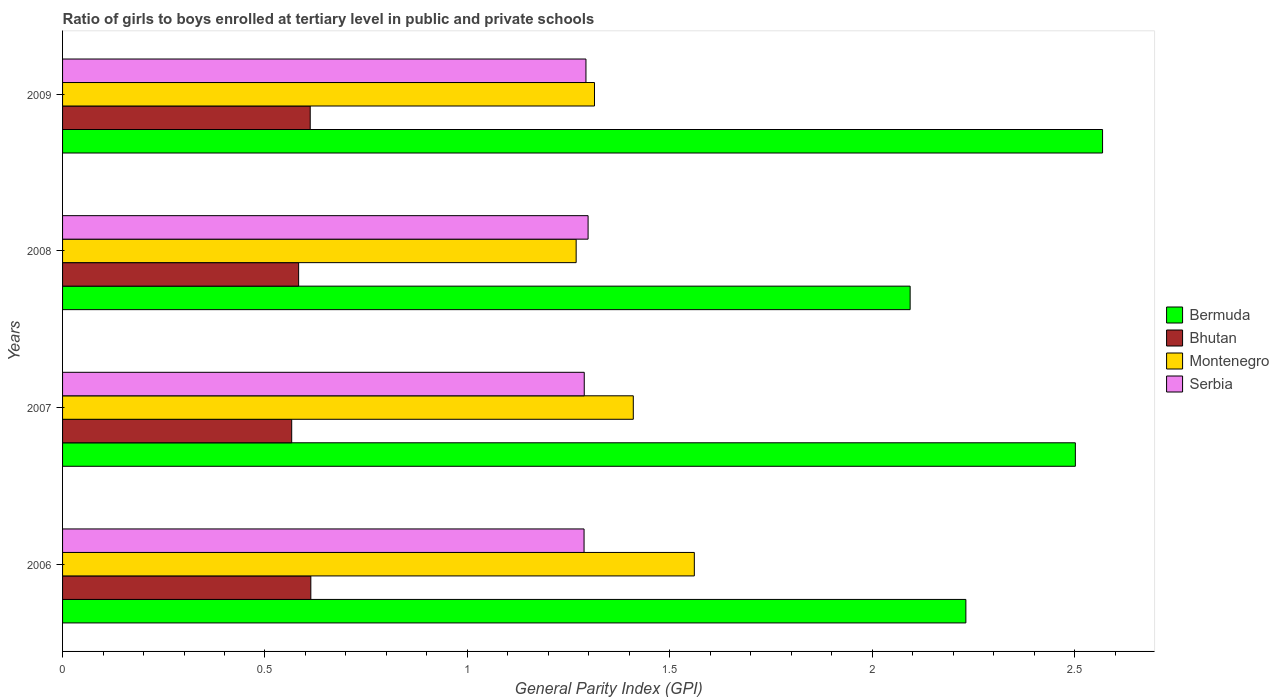How many different coloured bars are there?
Keep it short and to the point. 4. How many groups of bars are there?
Your answer should be compact. 4. Are the number of bars on each tick of the Y-axis equal?
Make the answer very short. Yes. How many bars are there on the 4th tick from the top?
Keep it short and to the point. 4. How many bars are there on the 4th tick from the bottom?
Make the answer very short. 4. What is the label of the 4th group of bars from the top?
Offer a terse response. 2006. In how many cases, is the number of bars for a given year not equal to the number of legend labels?
Provide a succinct answer. 0. What is the general parity index in Serbia in 2006?
Keep it short and to the point. 1.29. Across all years, what is the maximum general parity index in Bermuda?
Make the answer very short. 2.57. Across all years, what is the minimum general parity index in Serbia?
Your answer should be compact. 1.29. In which year was the general parity index in Bermuda maximum?
Offer a very short reply. 2009. What is the total general parity index in Bhutan in the graph?
Provide a succinct answer. 2.37. What is the difference between the general parity index in Bhutan in 2006 and that in 2008?
Provide a succinct answer. 0.03. What is the difference between the general parity index in Bhutan in 2006 and the general parity index in Bermuda in 2008?
Your answer should be compact. -1.48. What is the average general parity index in Bermuda per year?
Provide a short and direct response. 2.35. In the year 2006, what is the difference between the general parity index in Bermuda and general parity index in Montenegro?
Ensure brevity in your answer.  0.67. What is the ratio of the general parity index in Bhutan in 2007 to that in 2008?
Your answer should be compact. 0.97. What is the difference between the highest and the second highest general parity index in Montenegro?
Keep it short and to the point. 0.15. What is the difference between the highest and the lowest general parity index in Serbia?
Offer a terse response. 0.01. Is it the case that in every year, the sum of the general parity index in Bhutan and general parity index in Serbia is greater than the sum of general parity index in Bermuda and general parity index in Montenegro?
Provide a succinct answer. No. What does the 4th bar from the top in 2009 represents?
Make the answer very short. Bermuda. What does the 2nd bar from the bottom in 2009 represents?
Make the answer very short. Bhutan. Is it the case that in every year, the sum of the general parity index in Bhutan and general parity index in Bermuda is greater than the general parity index in Serbia?
Offer a terse response. Yes. Are all the bars in the graph horizontal?
Your answer should be compact. Yes. How many years are there in the graph?
Provide a succinct answer. 4. Are the values on the major ticks of X-axis written in scientific E-notation?
Keep it short and to the point. No. Does the graph contain grids?
Keep it short and to the point. No. How many legend labels are there?
Give a very brief answer. 4. What is the title of the graph?
Provide a succinct answer. Ratio of girls to boys enrolled at tertiary level in public and private schools. What is the label or title of the X-axis?
Your answer should be very brief. General Parity Index (GPI). What is the General Parity Index (GPI) in Bermuda in 2006?
Make the answer very short. 2.23. What is the General Parity Index (GPI) of Bhutan in 2006?
Give a very brief answer. 0.61. What is the General Parity Index (GPI) in Montenegro in 2006?
Keep it short and to the point. 1.56. What is the General Parity Index (GPI) of Serbia in 2006?
Ensure brevity in your answer.  1.29. What is the General Parity Index (GPI) in Bermuda in 2007?
Your answer should be very brief. 2.5. What is the General Parity Index (GPI) of Bhutan in 2007?
Keep it short and to the point. 0.57. What is the General Parity Index (GPI) in Montenegro in 2007?
Make the answer very short. 1.41. What is the General Parity Index (GPI) of Serbia in 2007?
Your answer should be compact. 1.29. What is the General Parity Index (GPI) of Bermuda in 2008?
Your answer should be compact. 2.09. What is the General Parity Index (GPI) of Bhutan in 2008?
Your answer should be very brief. 0.58. What is the General Parity Index (GPI) in Montenegro in 2008?
Provide a short and direct response. 1.27. What is the General Parity Index (GPI) in Serbia in 2008?
Offer a very short reply. 1.3. What is the General Parity Index (GPI) of Bermuda in 2009?
Provide a short and direct response. 2.57. What is the General Parity Index (GPI) in Bhutan in 2009?
Make the answer very short. 0.61. What is the General Parity Index (GPI) of Montenegro in 2009?
Provide a short and direct response. 1.31. What is the General Parity Index (GPI) of Serbia in 2009?
Keep it short and to the point. 1.29. Across all years, what is the maximum General Parity Index (GPI) in Bermuda?
Offer a terse response. 2.57. Across all years, what is the maximum General Parity Index (GPI) of Bhutan?
Offer a terse response. 0.61. Across all years, what is the maximum General Parity Index (GPI) in Montenegro?
Your answer should be very brief. 1.56. Across all years, what is the maximum General Parity Index (GPI) in Serbia?
Make the answer very short. 1.3. Across all years, what is the minimum General Parity Index (GPI) in Bermuda?
Provide a short and direct response. 2.09. Across all years, what is the minimum General Parity Index (GPI) in Bhutan?
Your answer should be compact. 0.57. Across all years, what is the minimum General Parity Index (GPI) in Montenegro?
Your response must be concise. 1.27. Across all years, what is the minimum General Parity Index (GPI) of Serbia?
Offer a very short reply. 1.29. What is the total General Parity Index (GPI) in Bermuda in the graph?
Provide a succinct answer. 9.4. What is the total General Parity Index (GPI) in Bhutan in the graph?
Give a very brief answer. 2.37. What is the total General Parity Index (GPI) of Montenegro in the graph?
Provide a succinct answer. 5.55. What is the total General Parity Index (GPI) of Serbia in the graph?
Your answer should be very brief. 5.17. What is the difference between the General Parity Index (GPI) of Bermuda in 2006 and that in 2007?
Your answer should be very brief. -0.27. What is the difference between the General Parity Index (GPI) in Bhutan in 2006 and that in 2007?
Make the answer very short. 0.05. What is the difference between the General Parity Index (GPI) of Montenegro in 2006 and that in 2007?
Your answer should be compact. 0.15. What is the difference between the General Parity Index (GPI) of Serbia in 2006 and that in 2007?
Provide a succinct answer. -0. What is the difference between the General Parity Index (GPI) of Bermuda in 2006 and that in 2008?
Your answer should be compact. 0.14. What is the difference between the General Parity Index (GPI) of Bhutan in 2006 and that in 2008?
Your response must be concise. 0.03. What is the difference between the General Parity Index (GPI) of Montenegro in 2006 and that in 2008?
Your answer should be very brief. 0.29. What is the difference between the General Parity Index (GPI) of Serbia in 2006 and that in 2008?
Make the answer very short. -0.01. What is the difference between the General Parity Index (GPI) in Bermuda in 2006 and that in 2009?
Give a very brief answer. -0.34. What is the difference between the General Parity Index (GPI) in Bhutan in 2006 and that in 2009?
Your answer should be compact. 0. What is the difference between the General Parity Index (GPI) in Montenegro in 2006 and that in 2009?
Provide a succinct answer. 0.25. What is the difference between the General Parity Index (GPI) in Serbia in 2006 and that in 2009?
Provide a succinct answer. -0. What is the difference between the General Parity Index (GPI) of Bermuda in 2007 and that in 2008?
Ensure brevity in your answer.  0.41. What is the difference between the General Parity Index (GPI) in Bhutan in 2007 and that in 2008?
Provide a short and direct response. -0.02. What is the difference between the General Parity Index (GPI) of Montenegro in 2007 and that in 2008?
Your answer should be compact. 0.14. What is the difference between the General Parity Index (GPI) of Serbia in 2007 and that in 2008?
Your answer should be compact. -0.01. What is the difference between the General Parity Index (GPI) in Bermuda in 2007 and that in 2009?
Offer a very short reply. -0.07. What is the difference between the General Parity Index (GPI) in Bhutan in 2007 and that in 2009?
Make the answer very short. -0.05. What is the difference between the General Parity Index (GPI) of Montenegro in 2007 and that in 2009?
Ensure brevity in your answer.  0.1. What is the difference between the General Parity Index (GPI) of Serbia in 2007 and that in 2009?
Your answer should be very brief. -0. What is the difference between the General Parity Index (GPI) of Bermuda in 2008 and that in 2009?
Your response must be concise. -0.48. What is the difference between the General Parity Index (GPI) in Bhutan in 2008 and that in 2009?
Give a very brief answer. -0.03. What is the difference between the General Parity Index (GPI) in Montenegro in 2008 and that in 2009?
Provide a short and direct response. -0.05. What is the difference between the General Parity Index (GPI) of Serbia in 2008 and that in 2009?
Make the answer very short. 0.01. What is the difference between the General Parity Index (GPI) of Bermuda in 2006 and the General Parity Index (GPI) of Bhutan in 2007?
Offer a terse response. 1.67. What is the difference between the General Parity Index (GPI) in Bermuda in 2006 and the General Parity Index (GPI) in Montenegro in 2007?
Give a very brief answer. 0.82. What is the difference between the General Parity Index (GPI) in Bermuda in 2006 and the General Parity Index (GPI) in Serbia in 2007?
Ensure brevity in your answer.  0.94. What is the difference between the General Parity Index (GPI) in Bhutan in 2006 and the General Parity Index (GPI) in Montenegro in 2007?
Provide a succinct answer. -0.8. What is the difference between the General Parity Index (GPI) of Bhutan in 2006 and the General Parity Index (GPI) of Serbia in 2007?
Make the answer very short. -0.68. What is the difference between the General Parity Index (GPI) in Montenegro in 2006 and the General Parity Index (GPI) in Serbia in 2007?
Keep it short and to the point. 0.27. What is the difference between the General Parity Index (GPI) in Bermuda in 2006 and the General Parity Index (GPI) in Bhutan in 2008?
Your response must be concise. 1.65. What is the difference between the General Parity Index (GPI) of Bermuda in 2006 and the General Parity Index (GPI) of Montenegro in 2008?
Provide a succinct answer. 0.96. What is the difference between the General Parity Index (GPI) in Bermuda in 2006 and the General Parity Index (GPI) in Serbia in 2008?
Ensure brevity in your answer.  0.93. What is the difference between the General Parity Index (GPI) in Bhutan in 2006 and the General Parity Index (GPI) in Montenegro in 2008?
Your response must be concise. -0.66. What is the difference between the General Parity Index (GPI) of Bhutan in 2006 and the General Parity Index (GPI) of Serbia in 2008?
Your answer should be compact. -0.68. What is the difference between the General Parity Index (GPI) in Montenegro in 2006 and the General Parity Index (GPI) in Serbia in 2008?
Make the answer very short. 0.26. What is the difference between the General Parity Index (GPI) of Bermuda in 2006 and the General Parity Index (GPI) of Bhutan in 2009?
Keep it short and to the point. 1.62. What is the difference between the General Parity Index (GPI) of Bermuda in 2006 and the General Parity Index (GPI) of Montenegro in 2009?
Provide a short and direct response. 0.92. What is the difference between the General Parity Index (GPI) of Bermuda in 2006 and the General Parity Index (GPI) of Serbia in 2009?
Provide a short and direct response. 0.94. What is the difference between the General Parity Index (GPI) of Bhutan in 2006 and the General Parity Index (GPI) of Montenegro in 2009?
Your response must be concise. -0.7. What is the difference between the General Parity Index (GPI) of Bhutan in 2006 and the General Parity Index (GPI) of Serbia in 2009?
Provide a short and direct response. -0.68. What is the difference between the General Parity Index (GPI) of Montenegro in 2006 and the General Parity Index (GPI) of Serbia in 2009?
Your answer should be compact. 0.27. What is the difference between the General Parity Index (GPI) of Bermuda in 2007 and the General Parity Index (GPI) of Bhutan in 2008?
Offer a very short reply. 1.92. What is the difference between the General Parity Index (GPI) in Bermuda in 2007 and the General Parity Index (GPI) in Montenegro in 2008?
Keep it short and to the point. 1.23. What is the difference between the General Parity Index (GPI) in Bermuda in 2007 and the General Parity Index (GPI) in Serbia in 2008?
Your answer should be compact. 1.2. What is the difference between the General Parity Index (GPI) of Bhutan in 2007 and the General Parity Index (GPI) of Montenegro in 2008?
Make the answer very short. -0.7. What is the difference between the General Parity Index (GPI) of Bhutan in 2007 and the General Parity Index (GPI) of Serbia in 2008?
Make the answer very short. -0.73. What is the difference between the General Parity Index (GPI) in Montenegro in 2007 and the General Parity Index (GPI) in Serbia in 2008?
Keep it short and to the point. 0.11. What is the difference between the General Parity Index (GPI) of Bermuda in 2007 and the General Parity Index (GPI) of Bhutan in 2009?
Keep it short and to the point. 1.89. What is the difference between the General Parity Index (GPI) of Bermuda in 2007 and the General Parity Index (GPI) of Montenegro in 2009?
Offer a very short reply. 1.19. What is the difference between the General Parity Index (GPI) in Bermuda in 2007 and the General Parity Index (GPI) in Serbia in 2009?
Keep it short and to the point. 1.21. What is the difference between the General Parity Index (GPI) of Bhutan in 2007 and the General Parity Index (GPI) of Montenegro in 2009?
Offer a terse response. -0.75. What is the difference between the General Parity Index (GPI) of Bhutan in 2007 and the General Parity Index (GPI) of Serbia in 2009?
Give a very brief answer. -0.73. What is the difference between the General Parity Index (GPI) of Montenegro in 2007 and the General Parity Index (GPI) of Serbia in 2009?
Offer a terse response. 0.12. What is the difference between the General Parity Index (GPI) in Bermuda in 2008 and the General Parity Index (GPI) in Bhutan in 2009?
Ensure brevity in your answer.  1.48. What is the difference between the General Parity Index (GPI) in Bermuda in 2008 and the General Parity Index (GPI) in Montenegro in 2009?
Offer a terse response. 0.78. What is the difference between the General Parity Index (GPI) of Bermuda in 2008 and the General Parity Index (GPI) of Serbia in 2009?
Your answer should be very brief. 0.8. What is the difference between the General Parity Index (GPI) of Bhutan in 2008 and the General Parity Index (GPI) of Montenegro in 2009?
Your response must be concise. -0.73. What is the difference between the General Parity Index (GPI) in Bhutan in 2008 and the General Parity Index (GPI) in Serbia in 2009?
Offer a very short reply. -0.71. What is the difference between the General Parity Index (GPI) in Montenegro in 2008 and the General Parity Index (GPI) in Serbia in 2009?
Your response must be concise. -0.02. What is the average General Parity Index (GPI) in Bermuda per year?
Ensure brevity in your answer.  2.35. What is the average General Parity Index (GPI) in Bhutan per year?
Offer a very short reply. 0.59. What is the average General Parity Index (GPI) in Montenegro per year?
Your answer should be very brief. 1.39. What is the average General Parity Index (GPI) in Serbia per year?
Make the answer very short. 1.29. In the year 2006, what is the difference between the General Parity Index (GPI) in Bermuda and General Parity Index (GPI) in Bhutan?
Provide a succinct answer. 1.62. In the year 2006, what is the difference between the General Parity Index (GPI) of Bermuda and General Parity Index (GPI) of Montenegro?
Provide a short and direct response. 0.67. In the year 2006, what is the difference between the General Parity Index (GPI) in Bermuda and General Parity Index (GPI) in Serbia?
Give a very brief answer. 0.94. In the year 2006, what is the difference between the General Parity Index (GPI) of Bhutan and General Parity Index (GPI) of Montenegro?
Your answer should be very brief. -0.95. In the year 2006, what is the difference between the General Parity Index (GPI) in Bhutan and General Parity Index (GPI) in Serbia?
Ensure brevity in your answer.  -0.67. In the year 2006, what is the difference between the General Parity Index (GPI) in Montenegro and General Parity Index (GPI) in Serbia?
Ensure brevity in your answer.  0.27. In the year 2007, what is the difference between the General Parity Index (GPI) in Bermuda and General Parity Index (GPI) in Bhutan?
Offer a terse response. 1.94. In the year 2007, what is the difference between the General Parity Index (GPI) of Bermuda and General Parity Index (GPI) of Montenegro?
Provide a succinct answer. 1.09. In the year 2007, what is the difference between the General Parity Index (GPI) of Bermuda and General Parity Index (GPI) of Serbia?
Ensure brevity in your answer.  1.21. In the year 2007, what is the difference between the General Parity Index (GPI) in Bhutan and General Parity Index (GPI) in Montenegro?
Offer a very short reply. -0.84. In the year 2007, what is the difference between the General Parity Index (GPI) in Bhutan and General Parity Index (GPI) in Serbia?
Give a very brief answer. -0.72. In the year 2007, what is the difference between the General Parity Index (GPI) of Montenegro and General Parity Index (GPI) of Serbia?
Your answer should be compact. 0.12. In the year 2008, what is the difference between the General Parity Index (GPI) of Bermuda and General Parity Index (GPI) of Bhutan?
Offer a very short reply. 1.51. In the year 2008, what is the difference between the General Parity Index (GPI) in Bermuda and General Parity Index (GPI) in Montenegro?
Your answer should be very brief. 0.82. In the year 2008, what is the difference between the General Parity Index (GPI) in Bermuda and General Parity Index (GPI) in Serbia?
Your response must be concise. 0.8. In the year 2008, what is the difference between the General Parity Index (GPI) of Bhutan and General Parity Index (GPI) of Montenegro?
Offer a terse response. -0.69. In the year 2008, what is the difference between the General Parity Index (GPI) of Bhutan and General Parity Index (GPI) of Serbia?
Keep it short and to the point. -0.71. In the year 2008, what is the difference between the General Parity Index (GPI) of Montenegro and General Parity Index (GPI) of Serbia?
Ensure brevity in your answer.  -0.03. In the year 2009, what is the difference between the General Parity Index (GPI) in Bermuda and General Parity Index (GPI) in Bhutan?
Your answer should be very brief. 1.96. In the year 2009, what is the difference between the General Parity Index (GPI) of Bermuda and General Parity Index (GPI) of Montenegro?
Your answer should be compact. 1.25. In the year 2009, what is the difference between the General Parity Index (GPI) in Bermuda and General Parity Index (GPI) in Serbia?
Make the answer very short. 1.28. In the year 2009, what is the difference between the General Parity Index (GPI) in Bhutan and General Parity Index (GPI) in Montenegro?
Your answer should be compact. -0.7. In the year 2009, what is the difference between the General Parity Index (GPI) of Bhutan and General Parity Index (GPI) of Serbia?
Make the answer very short. -0.68. In the year 2009, what is the difference between the General Parity Index (GPI) of Montenegro and General Parity Index (GPI) of Serbia?
Offer a terse response. 0.02. What is the ratio of the General Parity Index (GPI) of Bermuda in 2006 to that in 2007?
Provide a succinct answer. 0.89. What is the ratio of the General Parity Index (GPI) in Bhutan in 2006 to that in 2007?
Ensure brevity in your answer.  1.08. What is the ratio of the General Parity Index (GPI) in Montenegro in 2006 to that in 2007?
Make the answer very short. 1.11. What is the ratio of the General Parity Index (GPI) of Bermuda in 2006 to that in 2008?
Your answer should be very brief. 1.07. What is the ratio of the General Parity Index (GPI) in Bhutan in 2006 to that in 2008?
Provide a succinct answer. 1.05. What is the ratio of the General Parity Index (GPI) of Montenegro in 2006 to that in 2008?
Give a very brief answer. 1.23. What is the ratio of the General Parity Index (GPI) in Bermuda in 2006 to that in 2009?
Offer a very short reply. 0.87. What is the ratio of the General Parity Index (GPI) in Montenegro in 2006 to that in 2009?
Your response must be concise. 1.19. What is the ratio of the General Parity Index (GPI) of Bermuda in 2007 to that in 2008?
Your response must be concise. 1.19. What is the ratio of the General Parity Index (GPI) in Bhutan in 2007 to that in 2008?
Make the answer very short. 0.97. What is the ratio of the General Parity Index (GPI) of Montenegro in 2007 to that in 2008?
Offer a very short reply. 1.11. What is the ratio of the General Parity Index (GPI) in Bermuda in 2007 to that in 2009?
Your answer should be compact. 0.97. What is the ratio of the General Parity Index (GPI) in Bhutan in 2007 to that in 2009?
Offer a very short reply. 0.93. What is the ratio of the General Parity Index (GPI) of Montenegro in 2007 to that in 2009?
Your answer should be very brief. 1.07. What is the ratio of the General Parity Index (GPI) in Serbia in 2007 to that in 2009?
Offer a terse response. 1. What is the ratio of the General Parity Index (GPI) in Bermuda in 2008 to that in 2009?
Ensure brevity in your answer.  0.81. What is the ratio of the General Parity Index (GPI) of Bhutan in 2008 to that in 2009?
Your response must be concise. 0.95. What is the ratio of the General Parity Index (GPI) in Montenegro in 2008 to that in 2009?
Ensure brevity in your answer.  0.97. What is the ratio of the General Parity Index (GPI) of Serbia in 2008 to that in 2009?
Ensure brevity in your answer.  1. What is the difference between the highest and the second highest General Parity Index (GPI) in Bermuda?
Make the answer very short. 0.07. What is the difference between the highest and the second highest General Parity Index (GPI) of Bhutan?
Your answer should be compact. 0. What is the difference between the highest and the second highest General Parity Index (GPI) of Montenegro?
Offer a very short reply. 0.15. What is the difference between the highest and the second highest General Parity Index (GPI) of Serbia?
Give a very brief answer. 0.01. What is the difference between the highest and the lowest General Parity Index (GPI) in Bermuda?
Give a very brief answer. 0.48. What is the difference between the highest and the lowest General Parity Index (GPI) of Bhutan?
Your answer should be compact. 0.05. What is the difference between the highest and the lowest General Parity Index (GPI) of Montenegro?
Your answer should be compact. 0.29. 